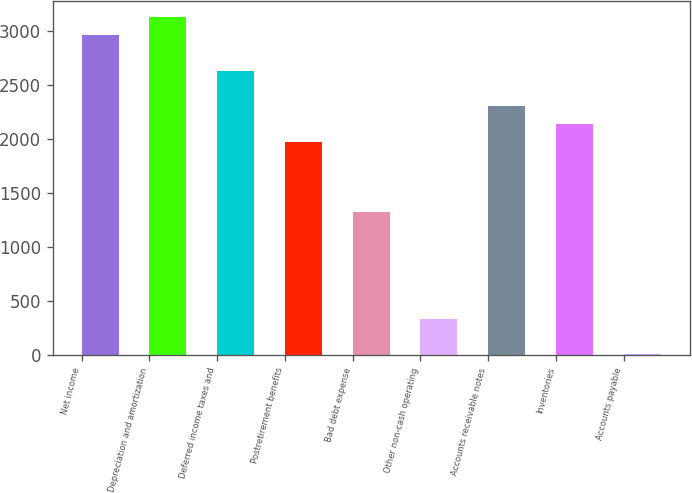Convert chart to OTSL. <chart><loc_0><loc_0><loc_500><loc_500><bar_chart><fcel>Net income<fcel>Depreciation and amortization<fcel>Deferred income taxes and<fcel>Postretirement benefits<fcel>Bad debt expense<fcel>Other non-cash operating<fcel>Accounts receivable notes<fcel>Inventories<fcel>Accounts payable<nl><fcel>2966<fcel>3130.5<fcel>2637<fcel>1979<fcel>1321<fcel>334<fcel>2308<fcel>2143.5<fcel>5<nl></chart> 